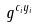Convert formula to latex. <formula><loc_0><loc_0><loc_500><loc_500>g ^ { c _ { i } y _ { i } }</formula> 